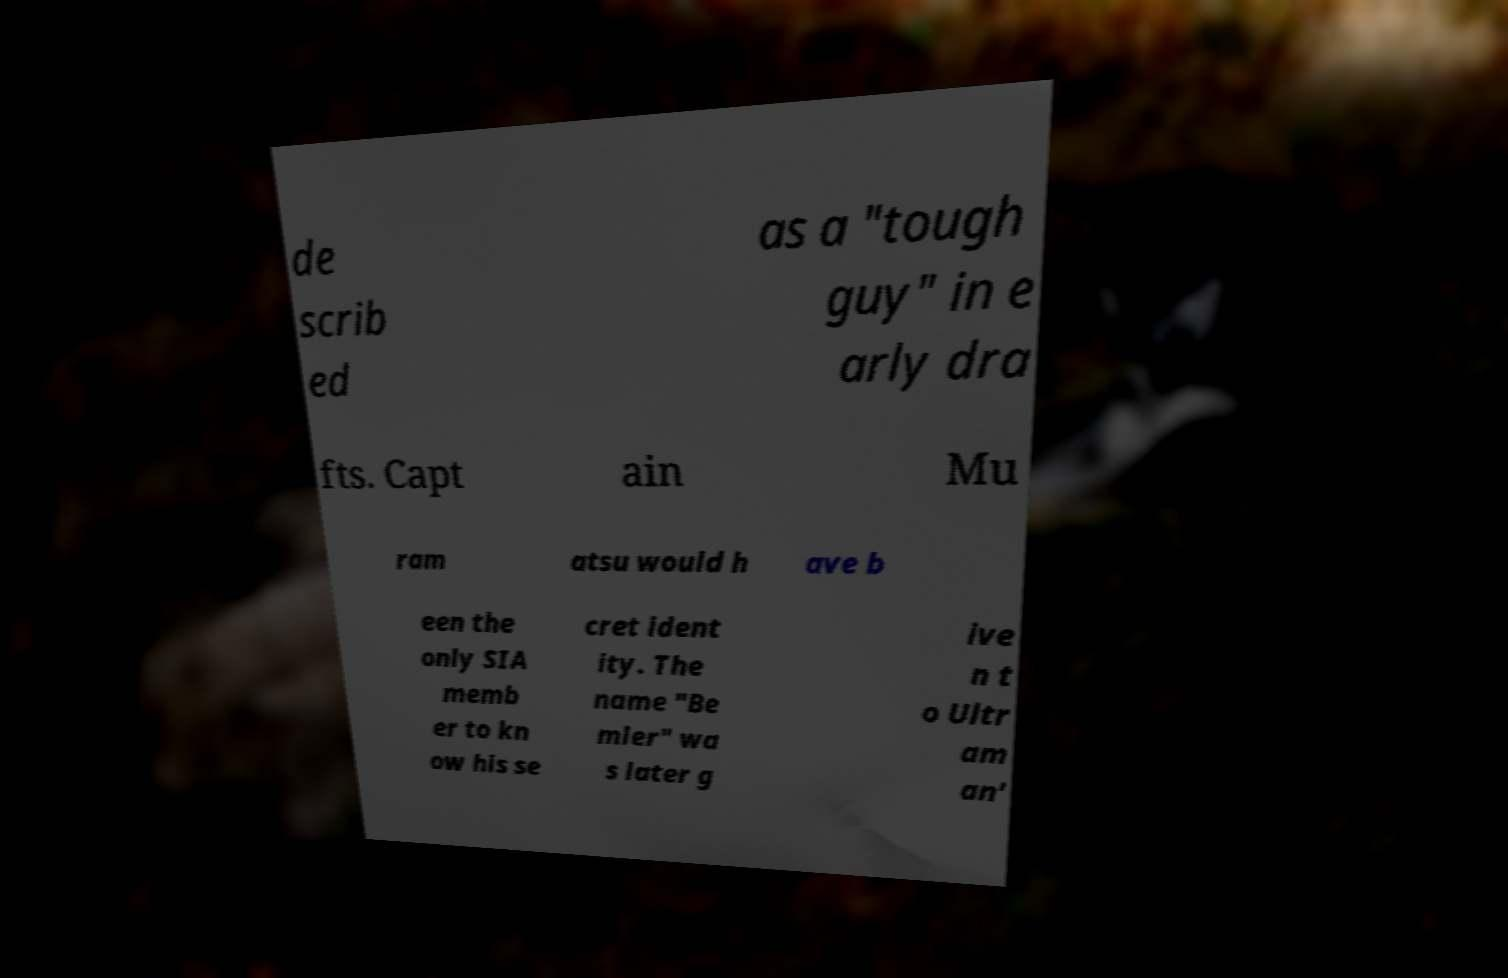I need the written content from this picture converted into text. Can you do that? de scrib ed as a "tough guy" in e arly dra fts. Capt ain Mu ram atsu would h ave b een the only SIA memb er to kn ow his se cret ident ity. The name "Be mler" wa s later g ive n t o Ultr am an' 